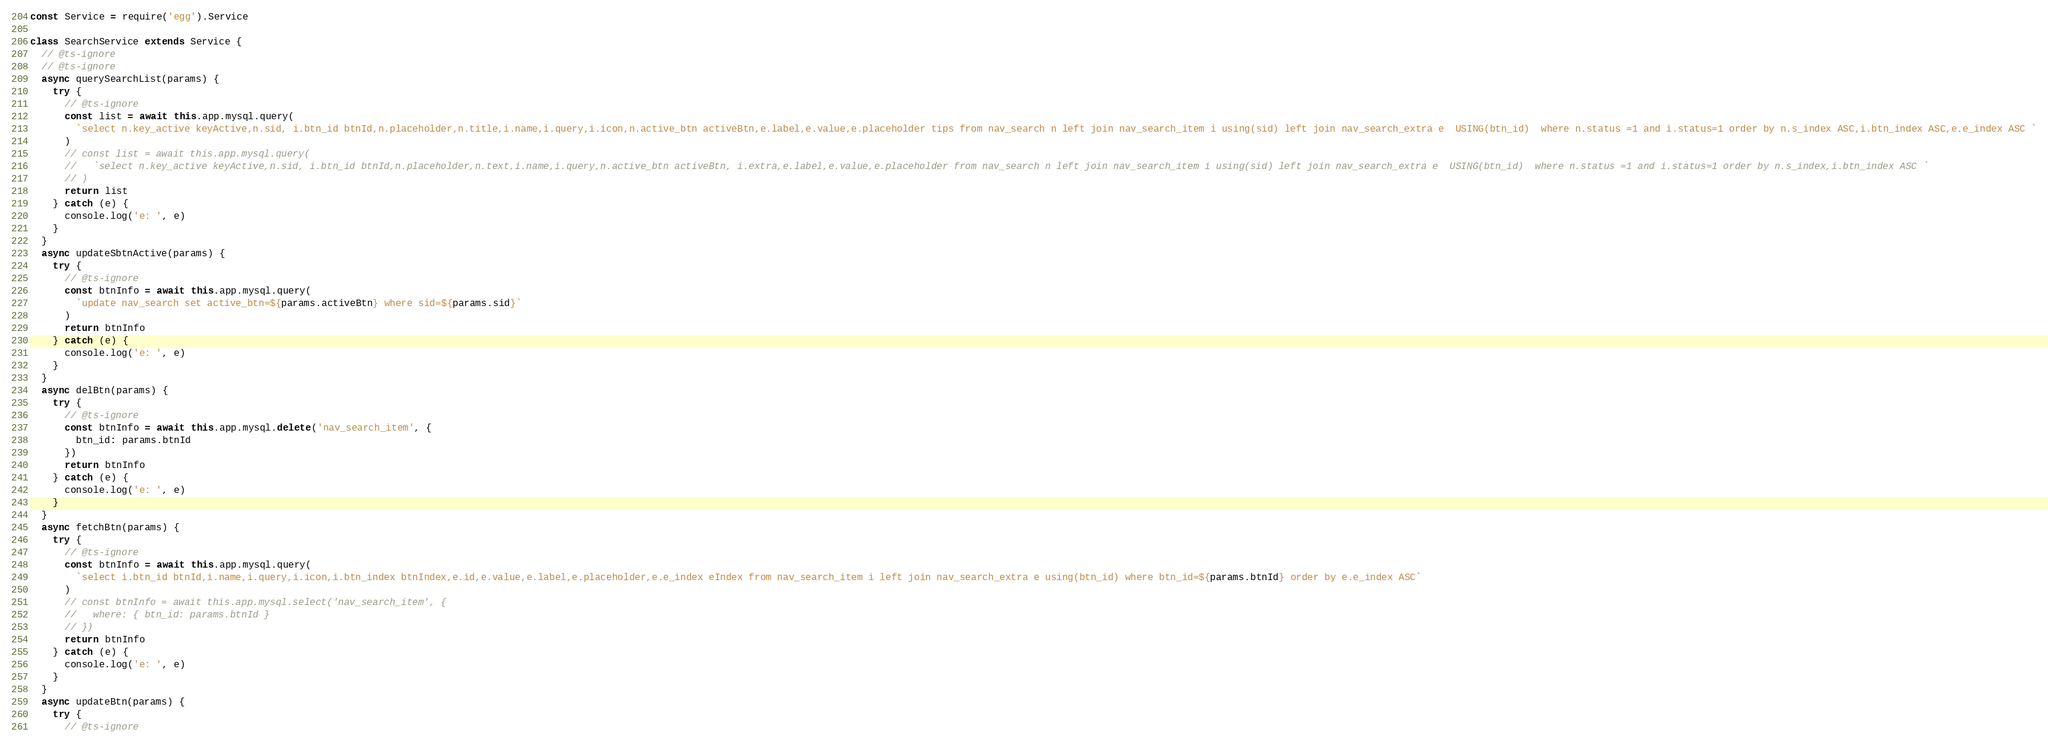<code> <loc_0><loc_0><loc_500><loc_500><_JavaScript_>const Service = require('egg').Service

class SearchService extends Service {
  // @ts-ignore
  // @ts-ignore
  async querySearchList(params) {
    try {
      // @ts-ignore
      const list = await this.app.mysql.query(
        `select n.key_active keyActive,n.sid, i.btn_id btnId,n.placeholder,n.title,i.name,i.query,i.icon,n.active_btn activeBtn,e.label,e.value,e.placeholder tips from nav_search n left join nav_search_item i using(sid) left join nav_search_extra e  USING(btn_id)  where n.status =1 and i.status=1 order by n.s_index ASC,i.btn_index ASC,e.e_index ASC `
      )
      // const list = await this.app.mysql.query(
      //   `select n.key_active keyActive,n.sid, i.btn_id btnId,n.placeholder,n.text,i.name,i.query,n.active_btn activeBtn, i.extra,e.label,e.value,e.placeholder from nav_search n left join nav_search_item i using(sid) left join nav_search_extra e  USING(btn_id)  where n.status =1 and i.status=1 order by n.s_index,i.btn_index ASC `
      // )
      return list
    } catch (e) {
      console.log('e: ', e)
    }
  }
  async updateSbtnActive(params) {
    try {
      // @ts-ignore
      const btnInfo = await this.app.mysql.query(
        `update nav_search set active_btn=${params.activeBtn} where sid=${params.sid}`
      )
      return btnInfo
    } catch (e) {
      console.log('e: ', e)
    }
  }
  async delBtn(params) {
    try {
      // @ts-ignore
      const btnInfo = await this.app.mysql.delete('nav_search_item', {
        btn_id: params.btnId
      })
      return btnInfo
    } catch (e) {
      console.log('e: ', e)
    }
  }
  async fetchBtn(params) {
    try {
      // @ts-ignore
      const btnInfo = await this.app.mysql.query(
        `select i.btn_id btnId,i.name,i.query,i.icon,i.btn_index btnIndex,e.id,e.value,e.label,e.placeholder,e.e_index eIndex from nav_search_item i left join nav_search_extra e using(btn_id) where btn_id=${params.btnId} order by e.e_index ASC`
      )
      // const btnInfo = await this.app.mysql.select('nav_search_item', {
      //   where: { btn_id: params.btnId }
      // })
      return btnInfo
    } catch (e) {
      console.log('e: ', e)
    }
  }
  async updateBtn(params) {
    try {
      // @ts-ignore</code> 